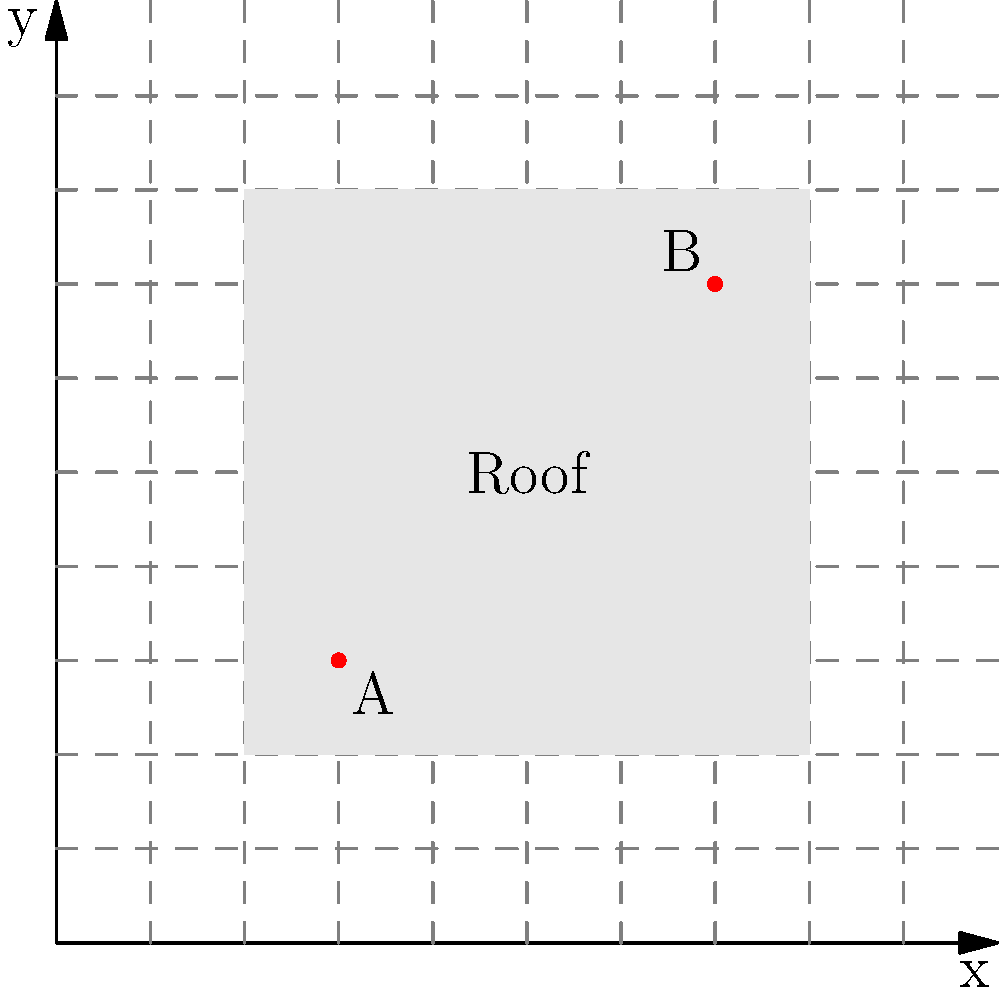A homeowner wants to install solar panels on their rectangular roof. The roof's dimensions are represented on a 2D coordinate grid, where each unit represents 1 meter. Point A is located at (3,3) and point B is at (7,7), representing opposite corners of the roof. What is the total area of the roof in square meters? To find the area of the rectangular roof, we need to follow these steps:

1. Determine the length of the roof:
   The x-coordinates of points A and B are 3 and 7, respectively.
   Length = $7 - 3 = 4$ units

2. Determine the width of the roof:
   The y-coordinates of points A and B are also 3 and 7, respectively.
   Width = $7 - 3 = 4$ units

3. Calculate the area of the roof:
   Area = Length $\times$ Width
   Area = $4 \times 4 = 16$ square units

4. Convert the area to square meters:
   Since each unit represents 1 meter, the area in square meters is the same as the area in square units.

Therefore, the total area of the roof is 16 square meters.
Answer: 16 square meters 